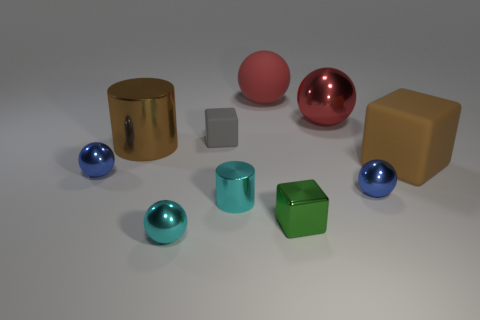There is a shiny cylinder that is the same color as the large rubber cube; what size is it?
Offer a terse response. Large. There is a rubber thing behind the gray object; is its color the same as the large metallic sphere?
Your answer should be compact. Yes. Are the big cube and the tiny green cube made of the same material?
Your answer should be compact. No. Are there any brown matte blocks that are behind the matte thing in front of the big metallic thing that is left of the gray thing?
Keep it short and to the point. No. Does the large metal cylinder have the same color as the large block?
Offer a very short reply. Yes. Is the number of blue metallic objects less than the number of large brown shiny cylinders?
Provide a short and direct response. No. Is the material of the brown object that is on the left side of the gray matte thing the same as the brown thing on the right side of the tiny green object?
Your answer should be compact. No. Are there fewer small shiny things that are to the right of the large brown metal cylinder than blue metal blocks?
Ensure brevity in your answer.  No. There is a metallic cylinder that is in front of the large cube; how many cyan metal balls are behind it?
Give a very brief answer. 0. How big is the metallic sphere that is on the right side of the brown cylinder and left of the large red rubber object?
Your response must be concise. Small. 